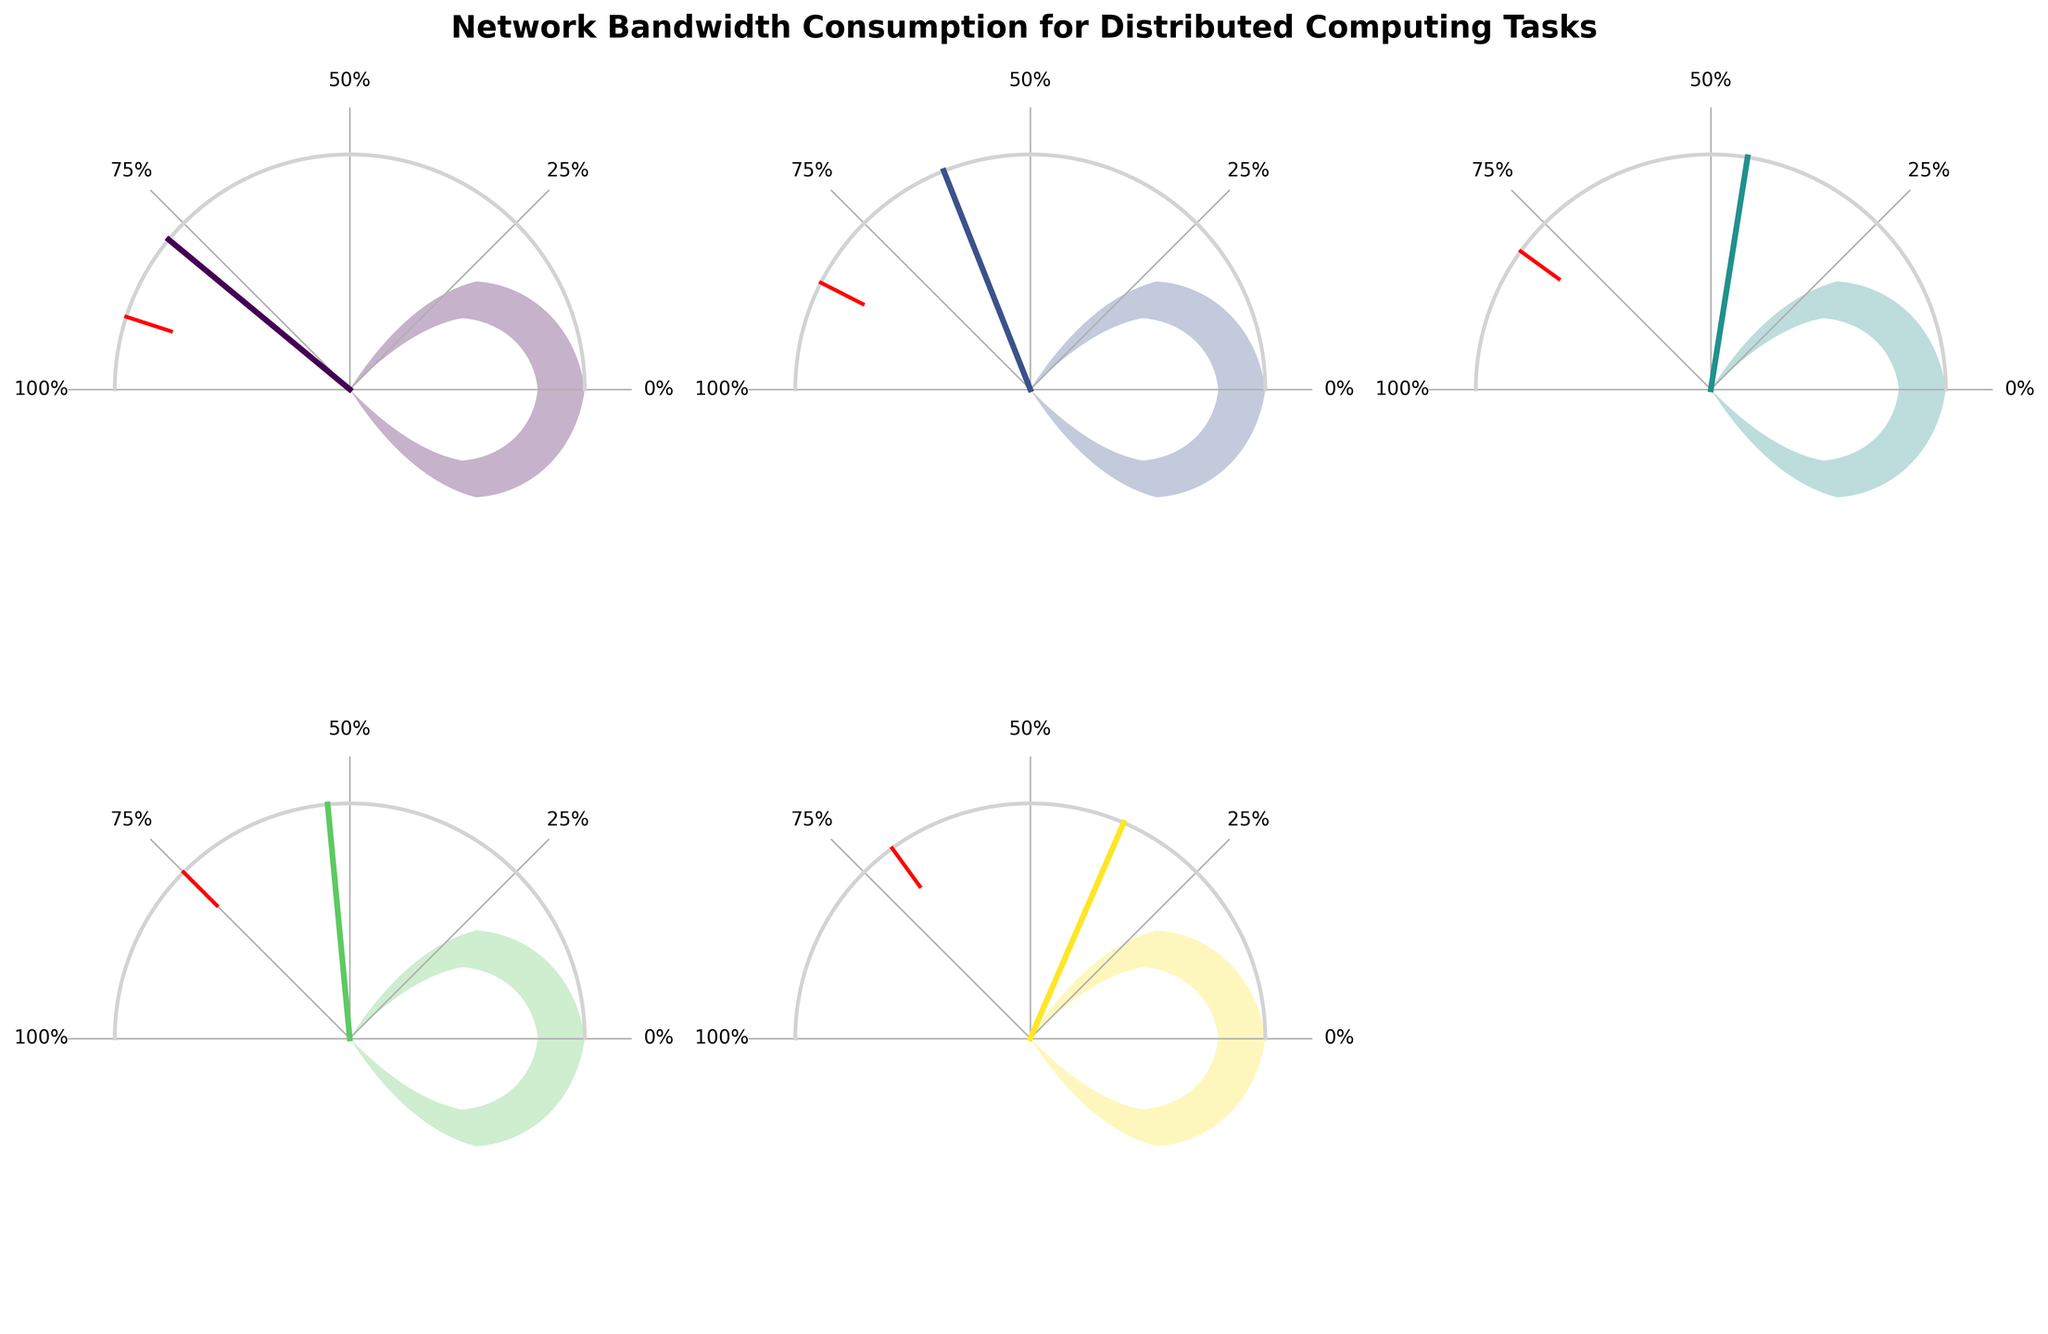What's the title of the figure? The title is displayed at the top of the figure and reads "Network Bandwidth Consumption for Distributed Computing Tasks".
Answer: Network Bandwidth Consumption for Distributed Computing Tasks How many networks are represented in the figure? By counting the gauge charts, you can see there are 5 networks displayed.
Answer: 5 Which network has the highest bandwidth usage percentage? The gauge chart for Folding@home shows the highest bandwidth usage at 78%.
Answer: Folding@home Which network has the lowest threshold? By looking at the red threshold indicators, Rosetta@home has the lowest threshold marked at 70%.
Answer: Rosetta@home How much higher is the bandwidth usage for Folding@home compared to Rosetta@home? Folding@home has a bandwidth usage of 78%, and Rosetta@home has 37%. Subtracting these gives 78% - 37% = 41%.
Answer: 41% Which network has its bandwidth usage closest to its threshold? Einstein@Home has a usage of 53% and a threshold of 75%, making the difference 22%, which is the smallest among the networks.
Answer: Einstein@Home Is BOINC's bandwidth usage greater than 75%? The gauge chart for BOINC shows a usage percentage of 62%, which is less than 75%.
Answer: No Which gauge chart shows a network that is using less than half of its bandwidth threshold? The bandwidth usage of Rosetta@home is 37%, and its threshold is 70%, thus 37% < 35% (which is half of the threshold).
Answer: Rosetta@home Are there any networks exceeding their threshold? All networks have their usage indicators (green color) below the red threshold markers; none exceed their thresholds.
Answer: No What range of percentages are used for the gauge's labels? The gauge labels on each chart are marked from 0% to 100%.
Answer: 0% to 100% 